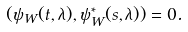Convert formula to latex. <formula><loc_0><loc_0><loc_500><loc_500>( \psi _ { W } ( t , \lambda ) , \psi _ { W } ^ { * } ( s , \lambda ) ) = 0 .</formula> 